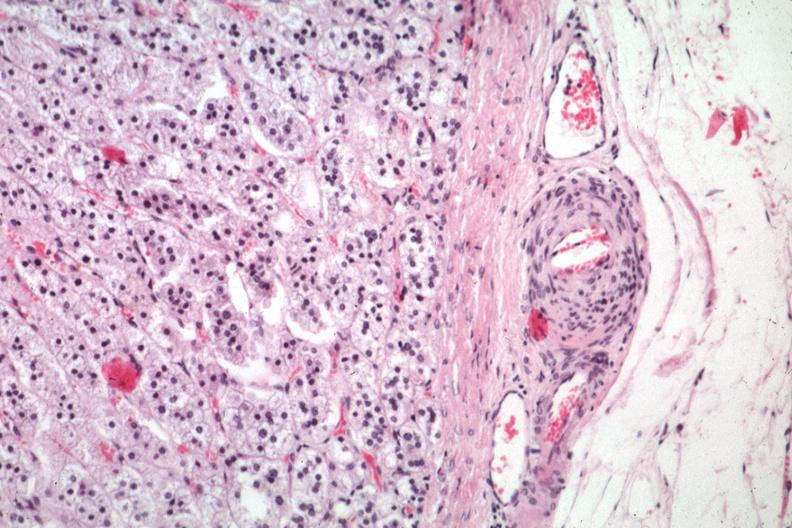what is present?
Answer the question using a single word or phrase. Adrenal 